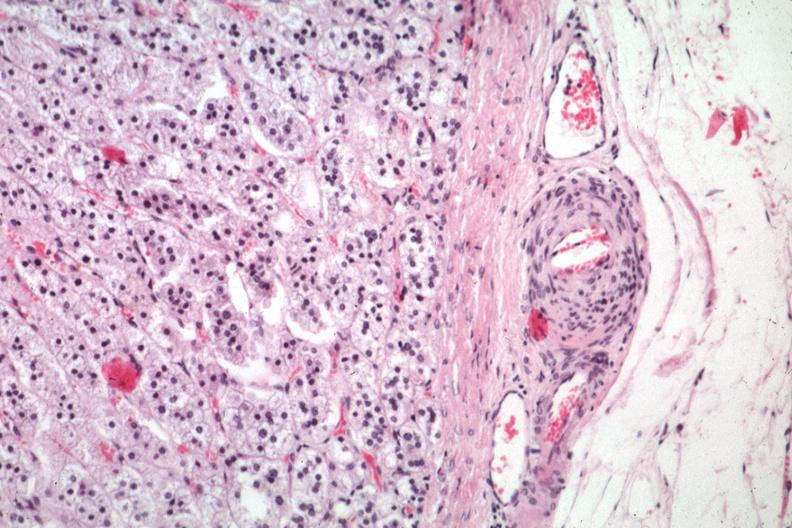what is present?
Answer the question using a single word or phrase. Adrenal 